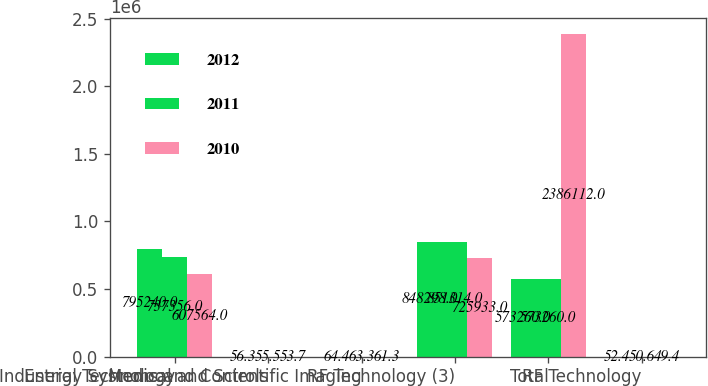Convert chart. <chart><loc_0><loc_0><loc_500><loc_500><stacked_bar_chart><ecel><fcel>Industrial Technology<fcel>Energy Systems and Controls<fcel>Medical and Scientific Imaging<fcel>RF Technology (3)<fcel>Total<fcel>RF Technology<nl><fcel>2012<fcel>795240<fcel>56.3<fcel>64.4<fcel>848298<fcel>573260<fcel>52.4<nl><fcel>2011<fcel>737356<fcel>55.5<fcel>63.3<fcel>851314<fcel>573260<fcel>50.6<nl><fcel>2010<fcel>607564<fcel>53.7<fcel>61.3<fcel>725933<fcel>2.38611e+06<fcel>49.4<nl></chart> 